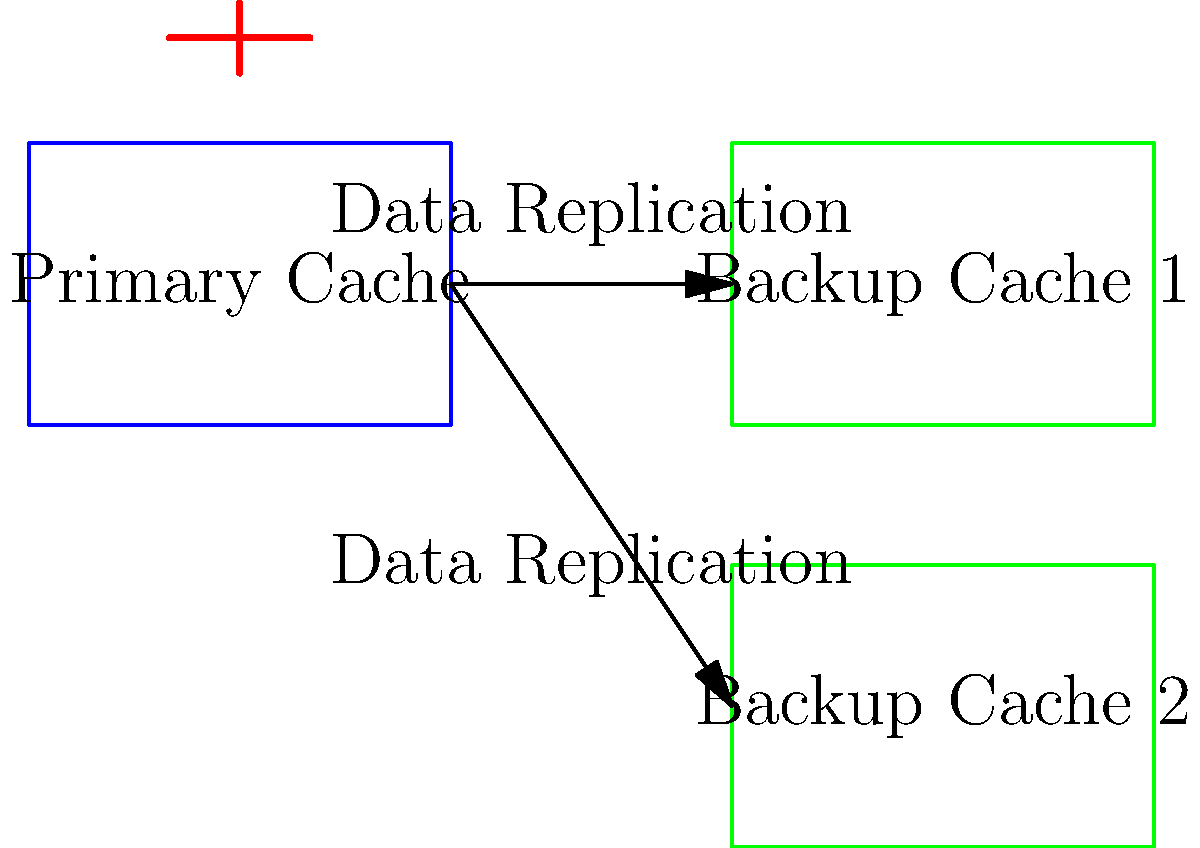In the distributed caching system shown above, what is the primary mechanism for ensuring data availability in case of a primary cache failure, and how does it impact system performance? To answer this question, let's break down the components and processes involved:

1. System Architecture:
   - The diagram shows a primary cache and two backup caches.
   - Arrows indicate data replication from the primary to the backup caches.

2. Failure Handling Mechanism:
   - The primary mechanism for ensuring data availability is data replication.
   - Data is continuously replicated from the primary cache to the backup caches.

3. Failover Process:
   - If the primary cache fails (indicated by the red failure symbol), one of the backup caches can take over.
   - This ensures that the data remains available even if the primary cache goes down.

4. Performance Impact:
   - Positive impact: High availability and fault tolerance.
   - Negative impact: Increased network traffic and latency due to replication.

5. Consistency Considerations:
   - Replication introduces the challenge of maintaining data consistency across all caches.
   - Depending on the replication strategy (synchronous or asynchronous), there might be a trade-off between consistency and performance.

6. Scalability:
   - This architecture allows for horizontal scaling by adding more backup caches.
   - However, it also increases the complexity of managing data consistency and replication.

In summary, the primary mechanism is data replication to backup caches, which ensures high availability but introduces performance overhead due to the replication process and the need to maintain data consistency across multiple cache instances.
Answer: Data replication; ensures availability but increases network traffic and latency. 